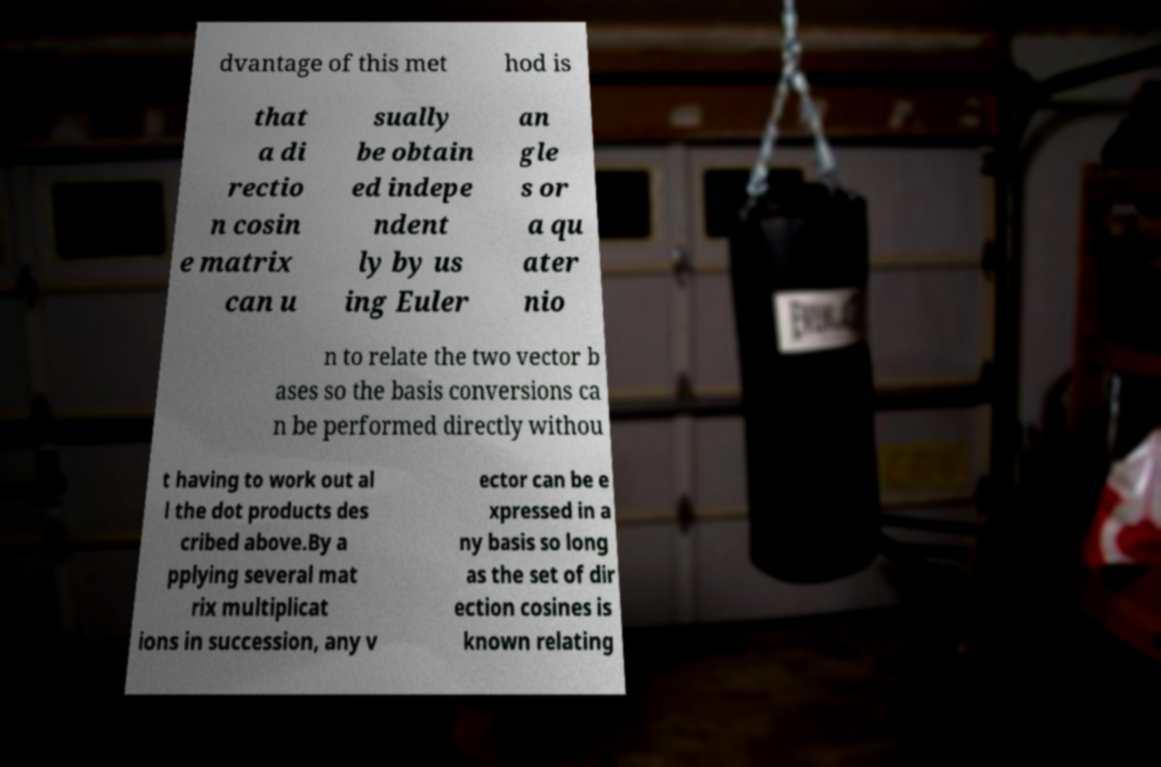Could you extract and type out the text from this image? dvantage of this met hod is that a di rectio n cosin e matrix can u sually be obtain ed indepe ndent ly by us ing Euler an gle s or a qu ater nio n to relate the two vector b ases so the basis conversions ca n be performed directly withou t having to work out al l the dot products des cribed above.By a pplying several mat rix multiplicat ions in succession, any v ector can be e xpressed in a ny basis so long as the set of dir ection cosines is known relating 